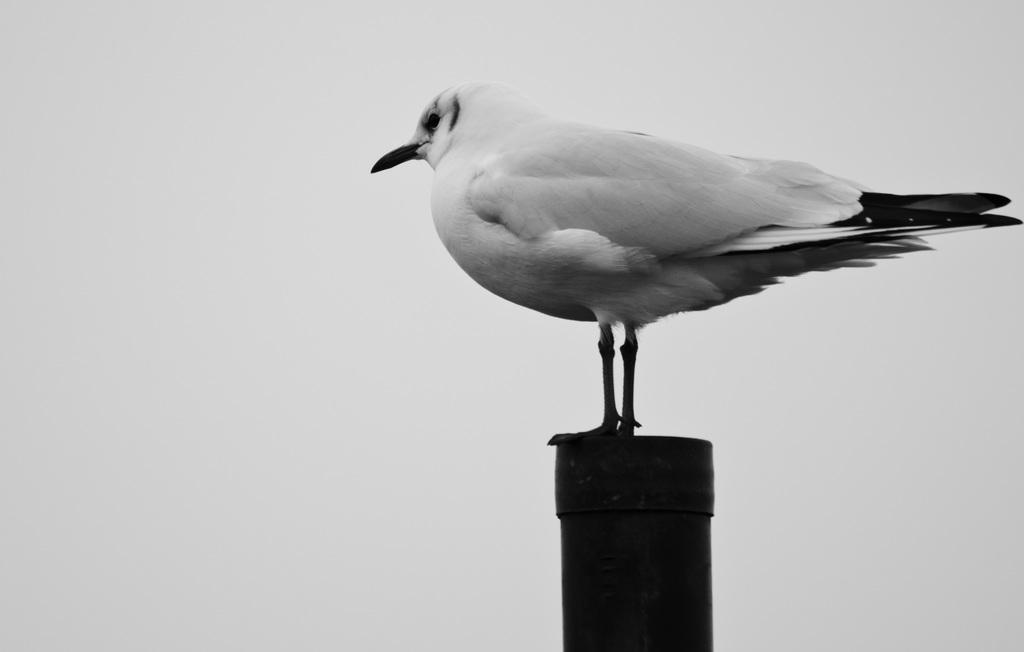What animal is standing in the image? There is a dove standing in the image. What object is at the bottom of the image? There is a pipe at the bottom of the image. What type of setting is depicted in the background of the image? The background of the image appears to be a plane. What color scheme is used in the image? The image is black and white. Where is the quiver of arrows located in the image? There is no quiver of arrows present in the image. What type of farm animals can be seen grazing in the image? There are no farm animals visible in the image; it features a dove and a pipe in a black and white, plane background. 